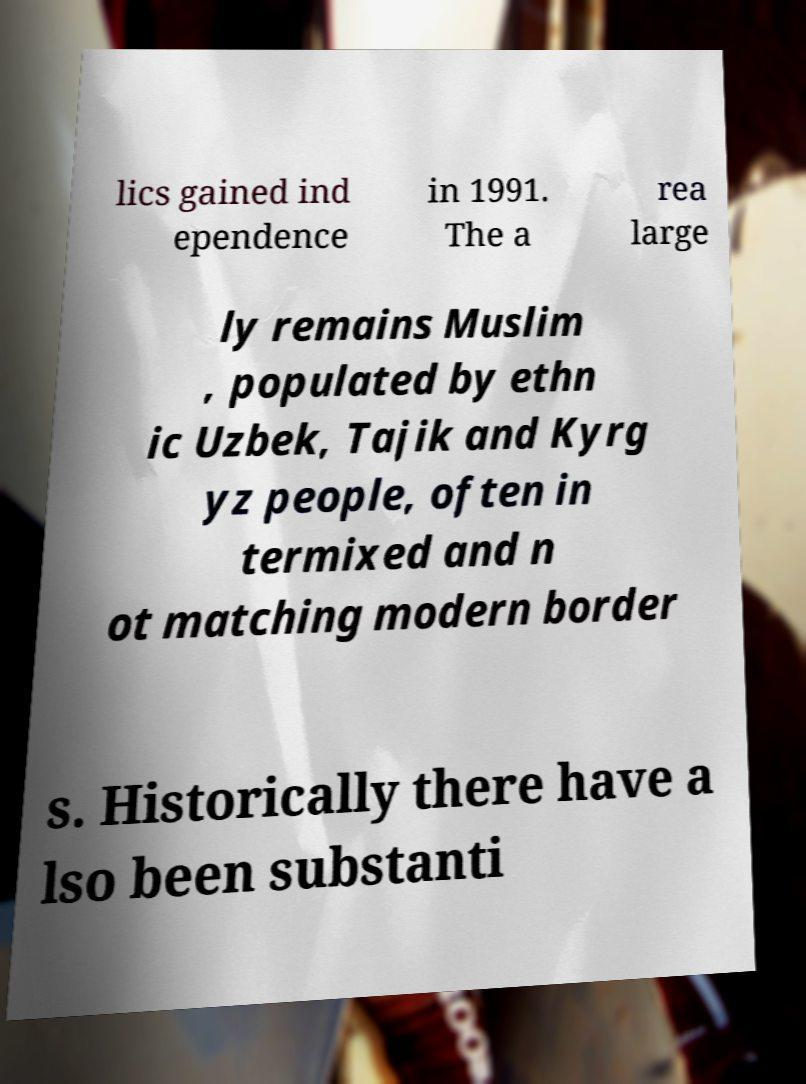What messages or text are displayed in this image? I need them in a readable, typed format. lics gained ind ependence in 1991. The a rea large ly remains Muslim , populated by ethn ic Uzbek, Tajik and Kyrg yz people, often in termixed and n ot matching modern border s. Historically there have a lso been substanti 